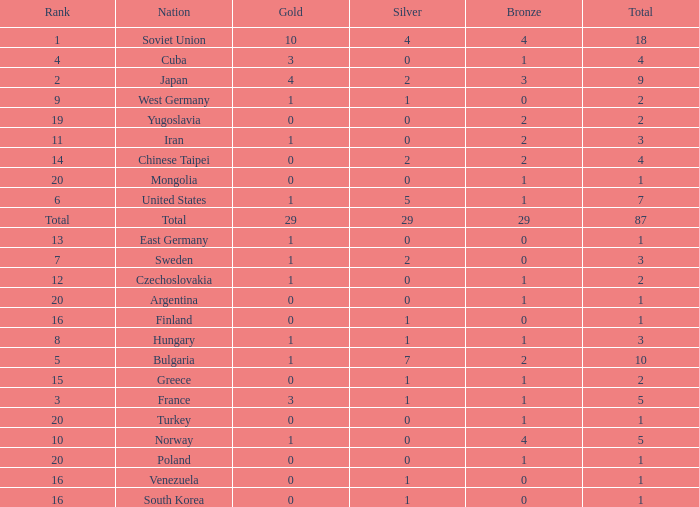Parse the table in full. {'header': ['Rank', 'Nation', 'Gold', 'Silver', 'Bronze', 'Total'], 'rows': [['1', 'Soviet Union', '10', '4', '4', '18'], ['4', 'Cuba', '3', '0', '1', '4'], ['2', 'Japan', '4', '2', '3', '9'], ['9', 'West Germany', '1', '1', '0', '2'], ['19', 'Yugoslavia', '0', '0', '2', '2'], ['11', 'Iran', '1', '0', '2', '3'], ['14', 'Chinese Taipei', '0', '2', '2', '4'], ['20', 'Mongolia', '0', '0', '1', '1'], ['6', 'United States', '1', '5', '1', '7'], ['Total', 'Total', '29', '29', '29', '87'], ['13', 'East Germany', '1', '0', '0', '1'], ['7', 'Sweden', '1', '2', '0', '3'], ['12', 'Czechoslovakia', '1', '0', '1', '2'], ['20', 'Argentina', '0', '0', '1', '1'], ['16', 'Finland', '0', '1', '0', '1'], ['8', 'Hungary', '1', '1', '1', '3'], ['5', 'Bulgaria', '1', '7', '2', '10'], ['15', 'Greece', '0', '1', '1', '2'], ['3', 'France', '3', '1', '1', '5'], ['20', 'Turkey', '0', '0', '1', '1'], ['10', 'Norway', '1', '0', '4', '5'], ['20', 'Poland', '0', '0', '1', '1'], ['16', 'Venezuela', '0', '1', '0', '1'], ['16', 'South Korea', '0', '1', '0', '1']]} Which rank has 1 silver medal and more than 1 gold medal? 3.0. 